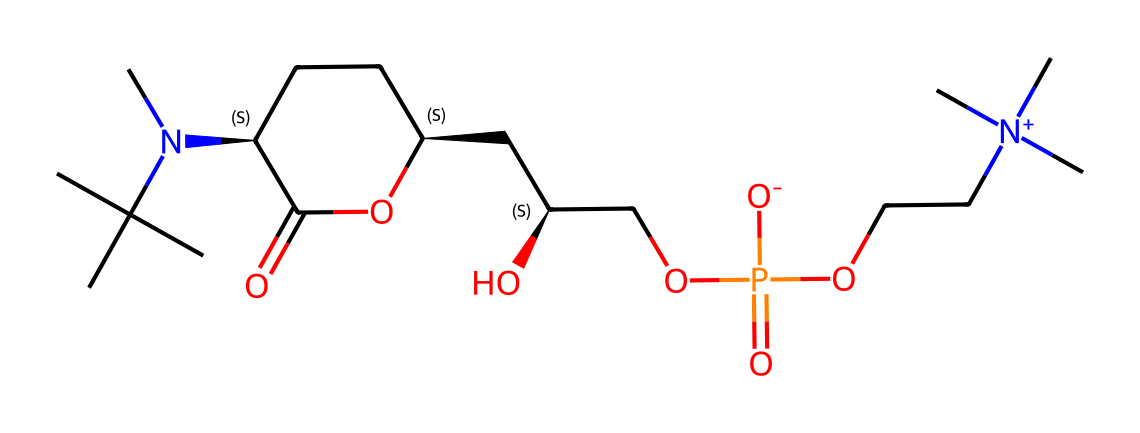What is the chemical name of the compound represented by the SMILES? The SMILES provided corresponds to a structure known as lecithin, which is a phospholipid and commonly used as an emulsifier in various applications, including food and cosmetics.
Answer: lecithin How many carbons are in the structure? By analyzing the SMILES, we can count the number of carbon atoms represented in the structure. There are 15 carbon atoms in the chemical structure of lecithin.
Answer: 15 What functional group is present in the molecule? The SMILES shows the presence of a phosphate group indicated by the "P(=O)([O-])" part. This is a key functional group for phospholipids like lecithin.
Answer: phosphate Does the molecule contain a nitrogen atom? Yes, the nitrogen atom can be identified in the structure by the presence of "N(C)" in the SMILES notation, indicating the presence of a nitrogen atom.
Answer: yes What is the main role of lecithin as an emulsifier? Lecithin acts as an emulsifier by reducing surface tension between two immiscible liquids, such as oil and water, facilitating their mixture, which is essential in many culinary applications.
Answer: emulsification Is lecithin a saturated or unsaturated lipid? The presence of double bonds in the carbon chains observed in the structure indicates that lecithin is an unsaturated lipid, which impacts its fluidity and functional properties.
Answer: unsaturated 